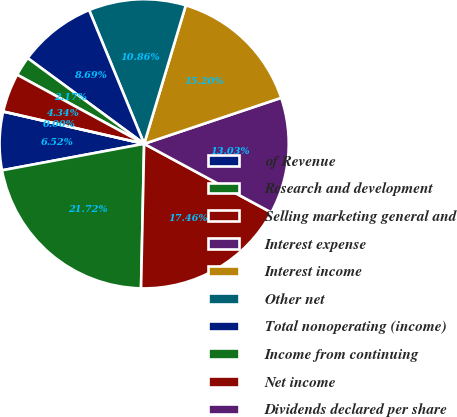<chart> <loc_0><loc_0><loc_500><loc_500><pie_chart><fcel>of Revenue<fcel>Research and development<fcel>Selling marketing general and<fcel>Interest expense<fcel>Interest income<fcel>Other net<fcel>Total nonoperating (income)<fcel>Income from continuing<fcel>Net income<fcel>Dividends declared per share<nl><fcel>6.52%<fcel>21.72%<fcel>17.46%<fcel>13.03%<fcel>15.2%<fcel>10.86%<fcel>8.69%<fcel>2.17%<fcel>4.34%<fcel>0.0%<nl></chart> 